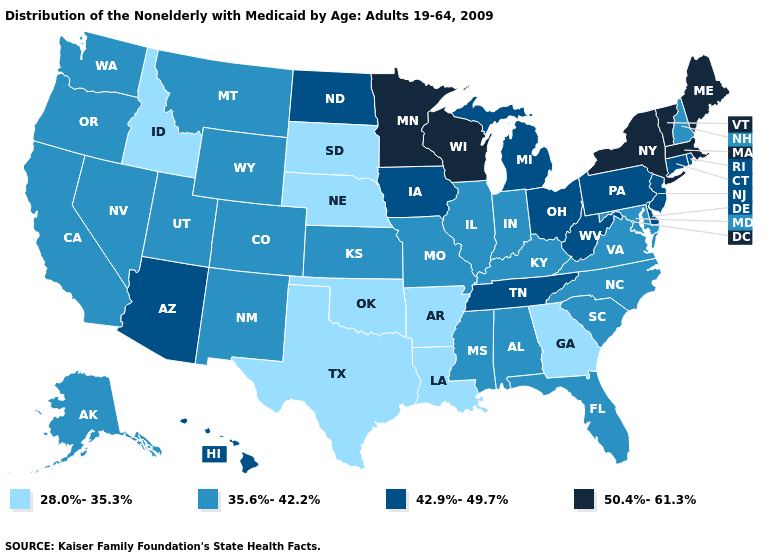What is the value of Oregon?
Write a very short answer. 35.6%-42.2%. What is the value of Tennessee?
Be succinct. 42.9%-49.7%. What is the value of Nevada?
Keep it brief. 35.6%-42.2%. Name the states that have a value in the range 50.4%-61.3%?
Quick response, please. Maine, Massachusetts, Minnesota, New York, Vermont, Wisconsin. Does Minnesota have the highest value in the MidWest?
Be succinct. Yes. Does Arkansas have the lowest value in the USA?
Write a very short answer. Yes. Does Nevada have a lower value than Florida?
Give a very brief answer. No. Does Georgia have the highest value in the USA?
Concise answer only. No. What is the highest value in states that border Ohio?
Keep it brief. 42.9%-49.7%. What is the value of Virginia?
Be succinct. 35.6%-42.2%. Does New Jersey have the highest value in the Northeast?
Give a very brief answer. No. How many symbols are there in the legend?
Be succinct. 4. Name the states that have a value in the range 35.6%-42.2%?
Give a very brief answer. Alabama, Alaska, California, Colorado, Florida, Illinois, Indiana, Kansas, Kentucky, Maryland, Mississippi, Missouri, Montana, Nevada, New Hampshire, New Mexico, North Carolina, Oregon, South Carolina, Utah, Virginia, Washington, Wyoming. What is the highest value in states that border Tennessee?
Answer briefly. 35.6%-42.2%. What is the highest value in the West ?
Quick response, please. 42.9%-49.7%. 